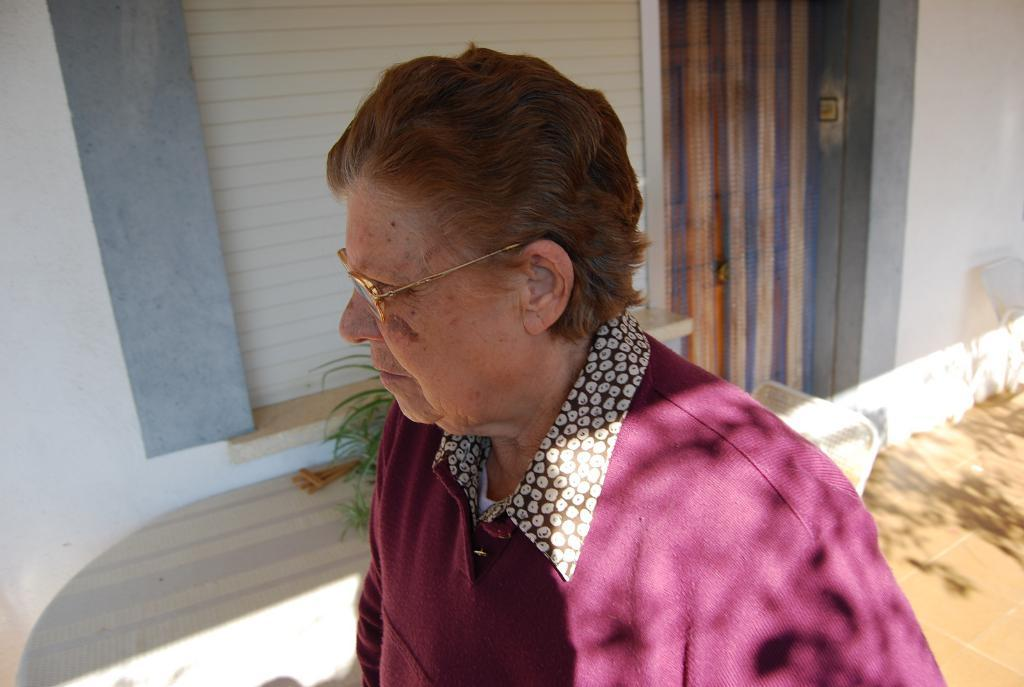What is the main subject of the image? There is a person in the image. What is the person wearing? The person is wearing a pink dress. What can be seen in the background of the image? There is a table, a chair, the floor, a wall, and a window in the background of the image. How many friends are visible in the image? There is no indication of friends in the image; it only features a person wearing a pink dress. What type of calculator is on the table in the image? There is no calculator present in the image; it only features a person, a pink dress, and background elements. 